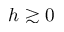<formula> <loc_0><loc_0><loc_500><loc_500>h \gtrsim 0</formula> 